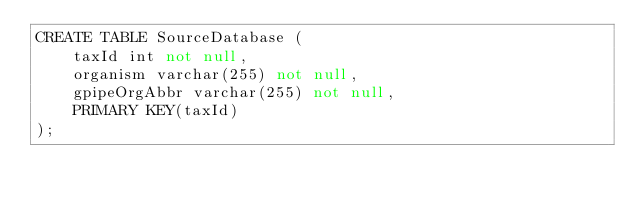<code> <loc_0><loc_0><loc_500><loc_500><_SQL_>CREATE TABLE SourceDatabase (
    taxId int not null,
    organism varchar(255) not null,
    gpipeOrgAbbr varchar(255) not null,
    PRIMARY KEY(taxId)
);
</code> 